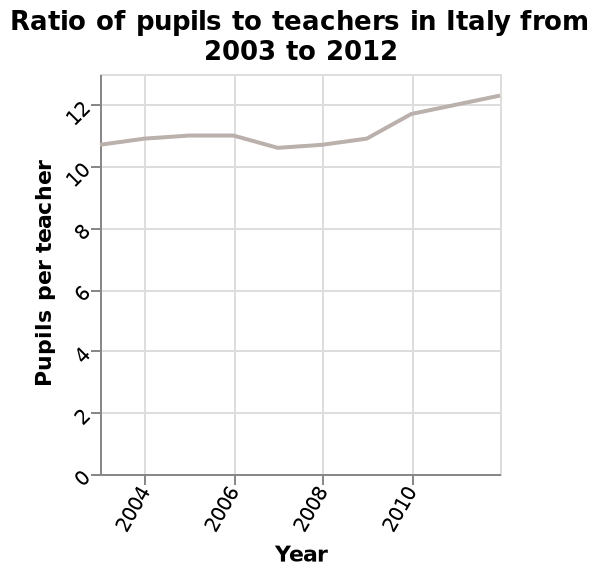<image>
What does the x-axis represent in the line plot?  The x-axis in the line plot represents the Year. What does the line plot show? The line plot shows the changes in the ratio of pupils to teachers in Italy from 2003 to 2012. When does the ratio of pupils to teachers drop below 10?  The ratio of pupils to teachers does not drop below 10 between 2003 and 2012. Does the line plot show the changes in the ratio of teachers to pupils in Italy from 2003 to 2012? No.The line plot shows the changes in the ratio of pupils to teachers in Italy from 2003 to 2012. 